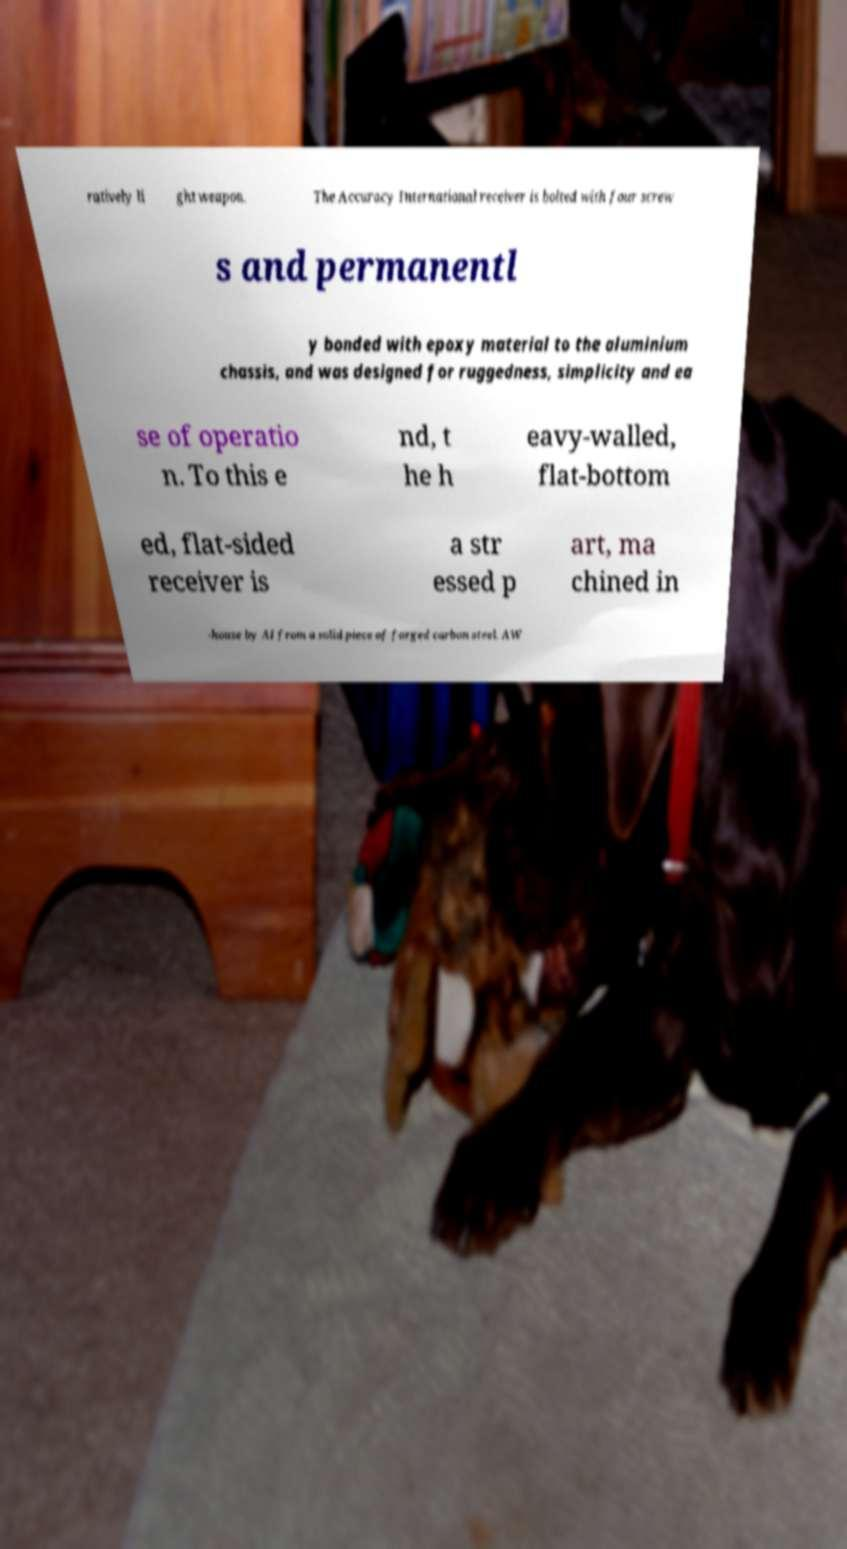I need the written content from this picture converted into text. Can you do that? ratively li ght weapon. The Accuracy International receiver is bolted with four screw s and permanentl y bonded with epoxy material to the aluminium chassis, and was designed for ruggedness, simplicity and ea se of operatio n. To this e nd, t he h eavy-walled, flat-bottom ed, flat-sided receiver is a str essed p art, ma chined in -house by AI from a solid piece of forged carbon steel. AW 